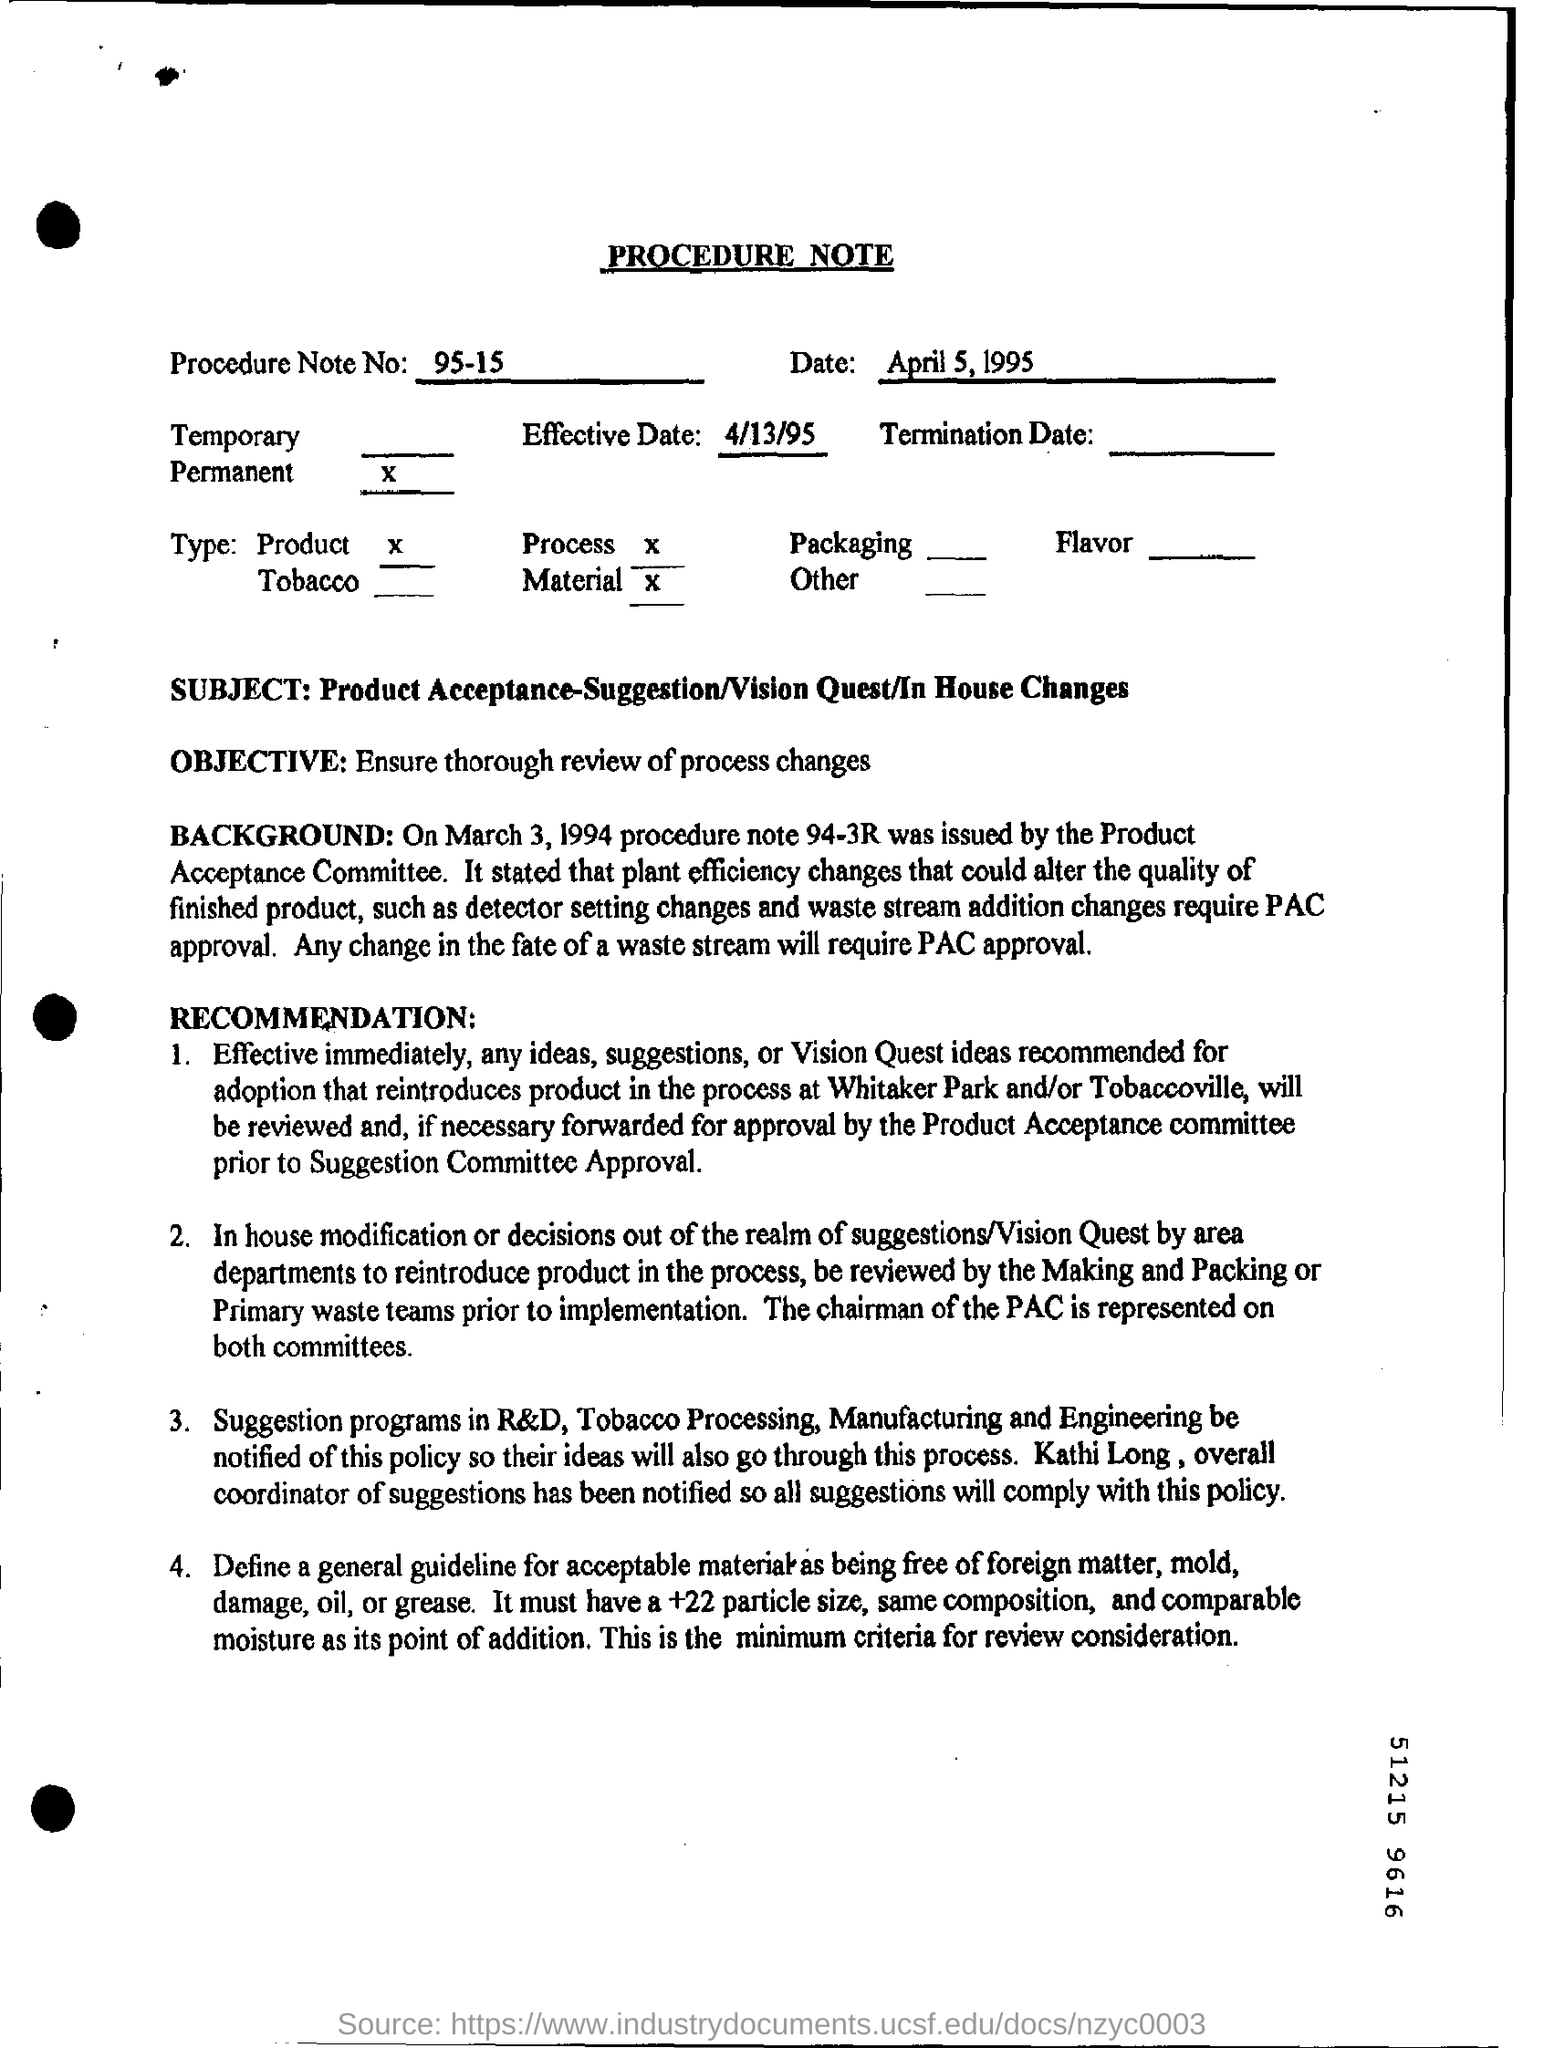What kind of document is this?
Keep it short and to the point. PROCEDURE NOTE. What is the Effective Date mentioned in this document?
Keep it short and to the point. 4/13/95. What is the Procedure Note No of the given document?
Ensure brevity in your answer.  95-15. What is the objective of the procedure note given?
Keep it short and to the point. Ensure thorough review of process changes. What is the subject of  this procedure note?
Your answer should be very brief. Product Acceptance-Suggestion/Vision Quest/In House Changes. What approval is required inorder to  make any change in the fate of a waste stream?
Give a very brief answer. PAC. 